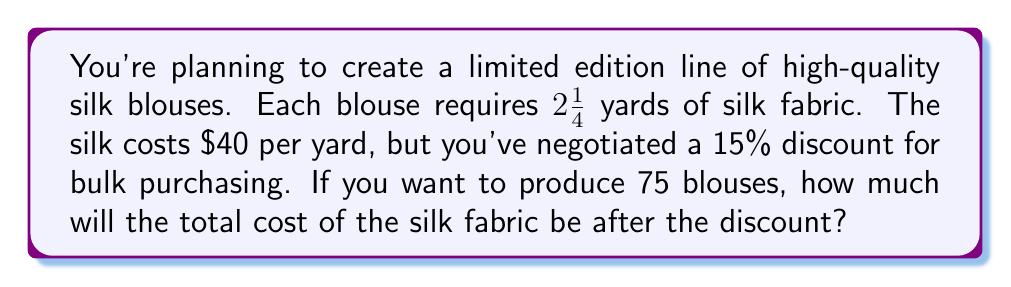Help me with this question. Let's break this down step-by-step:

1) First, calculate the total yards of silk needed:
   $2\frac{1}{4}$ yards per blouse $\times 75$ blouses
   $= \frac{9}{4} \times 75 = 168.75$ yards

2) Calculate the cost of silk before the discount:
   $168.75$ yards $\times \$40$ per yard $= \$6,750$

3) Calculate the discount amount:
   $15\%$ of $\$6,750 = 0.15 \times \$6,750 = \$1,012.50$

4) Subtract the discount from the original price:
   $\$6,750 - \$1,012.50 = \$5,737.50$

Therefore, the total cost of silk fabric after the discount is $\$5,737.50$.
Answer: $\$5,737.50$ 